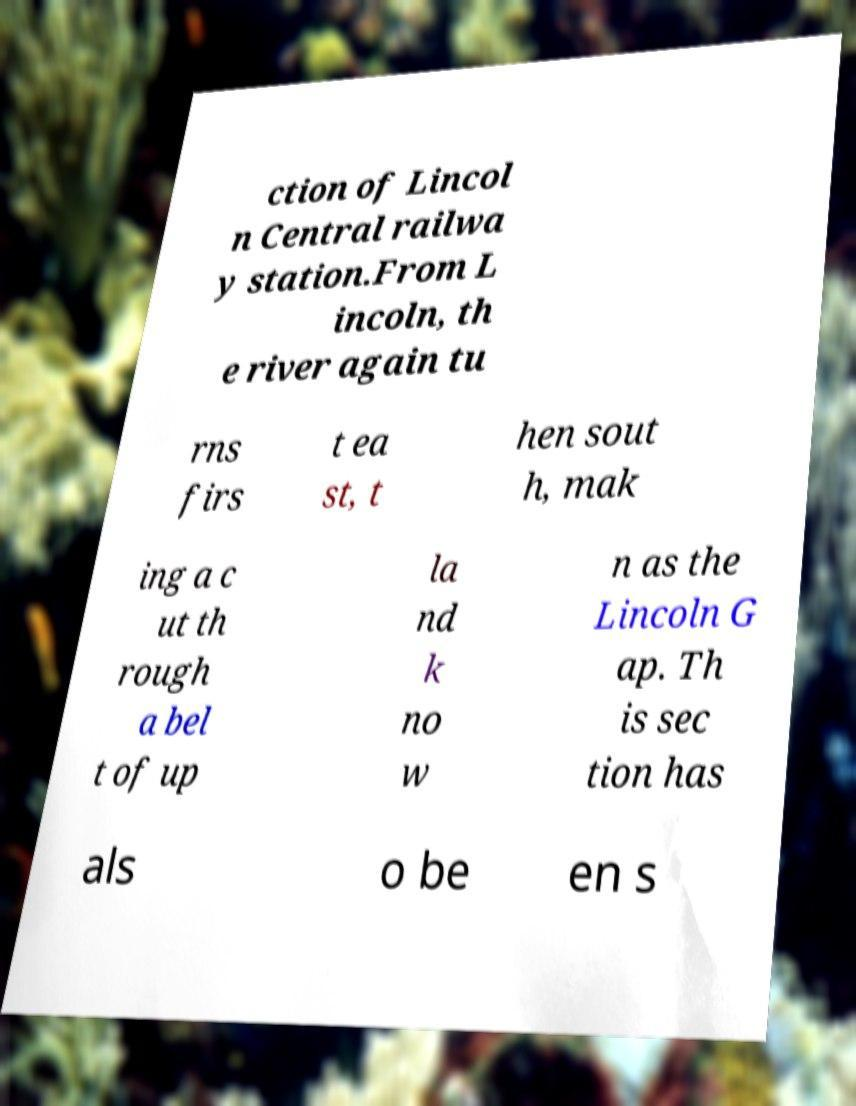There's text embedded in this image that I need extracted. Can you transcribe it verbatim? ction of Lincol n Central railwa y station.From L incoln, th e river again tu rns firs t ea st, t hen sout h, mak ing a c ut th rough a bel t of up la nd k no w n as the Lincoln G ap. Th is sec tion has als o be en s 